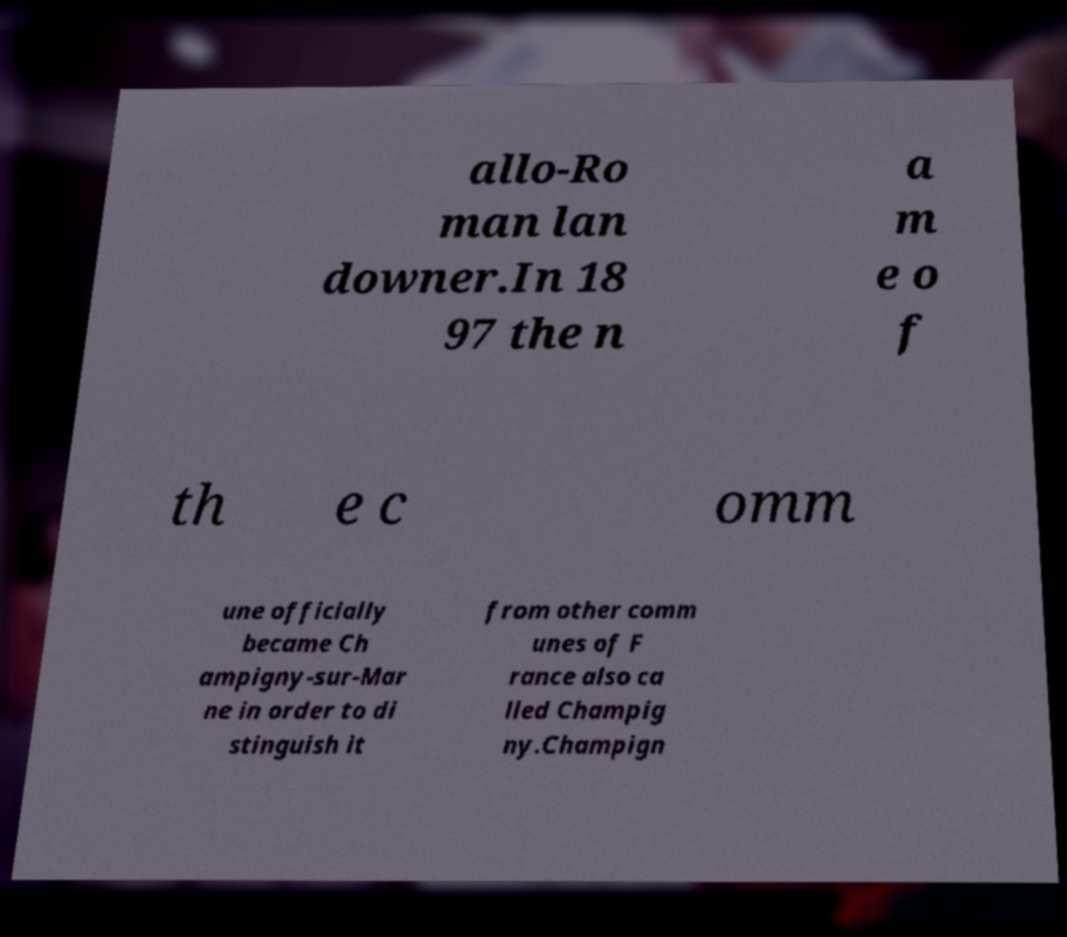What messages or text are displayed in this image? I need them in a readable, typed format. allo-Ro man lan downer.In 18 97 the n a m e o f th e c omm une officially became Ch ampigny-sur-Mar ne in order to di stinguish it from other comm unes of F rance also ca lled Champig ny.Champign 